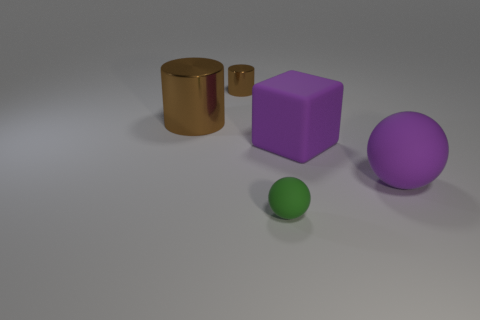Add 4 large blue rubber blocks. How many objects exist? 9 Subtract all balls. How many objects are left? 3 Add 2 tiny brown shiny cylinders. How many tiny brown shiny cylinders are left? 3 Add 2 big brown objects. How many big brown objects exist? 3 Subtract 2 brown cylinders. How many objects are left? 3 Subtract all tiny objects. Subtract all big purple blocks. How many objects are left? 2 